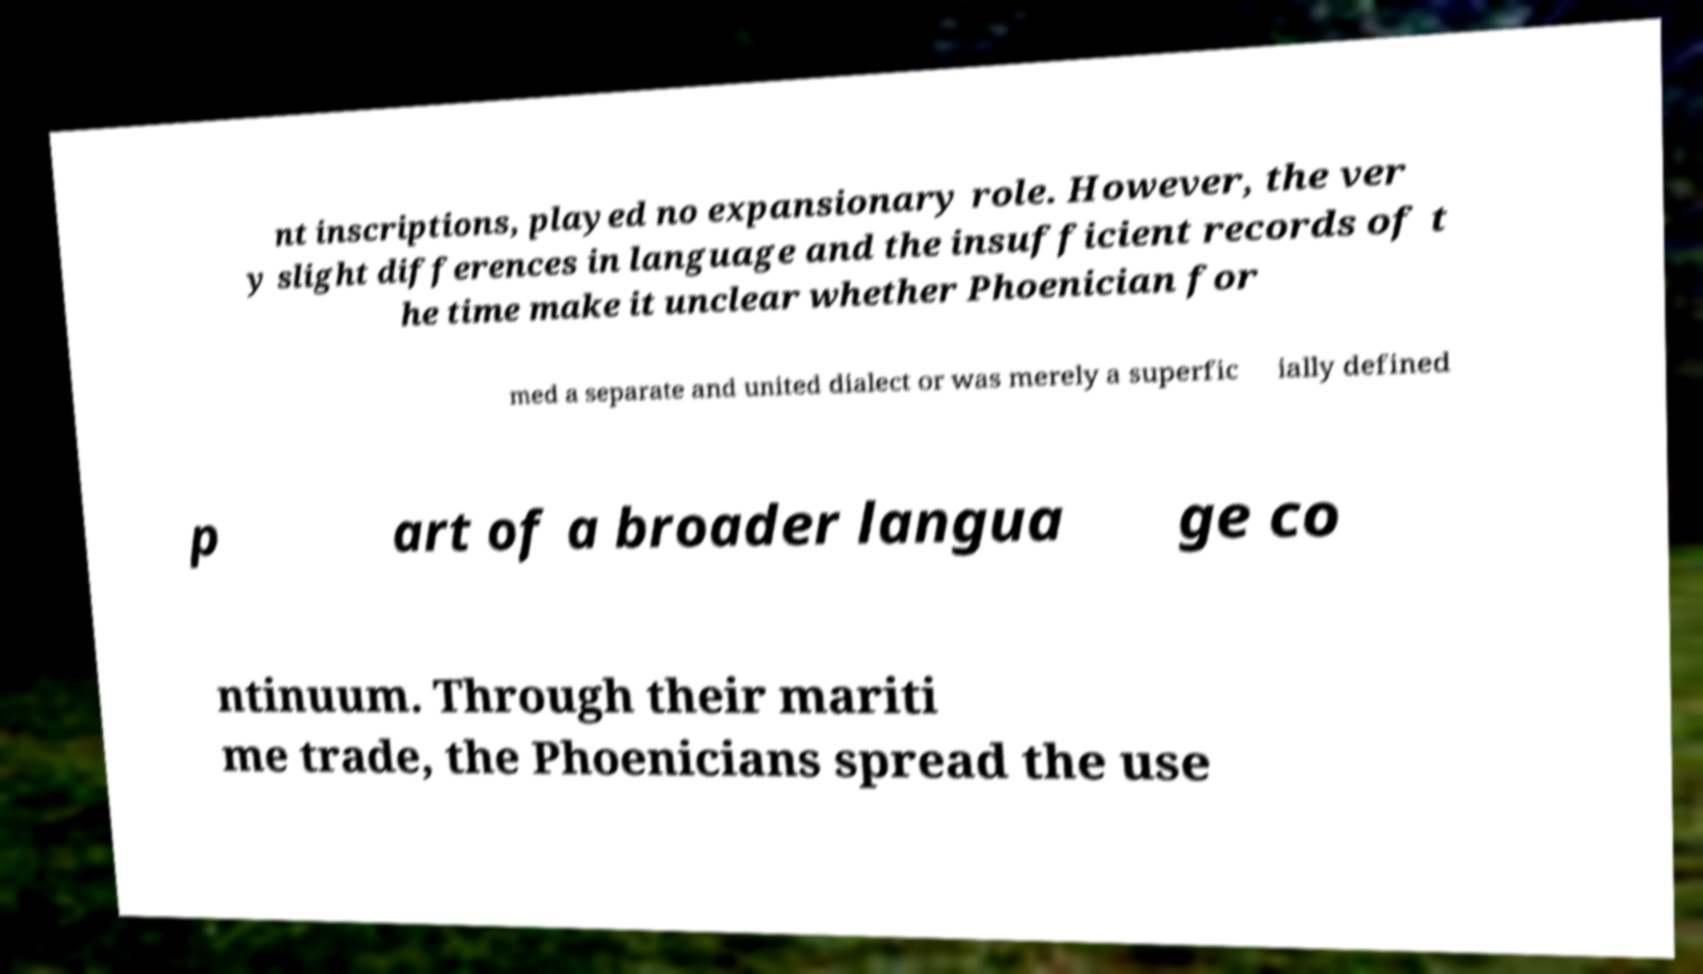Can you read and provide the text displayed in the image?This photo seems to have some interesting text. Can you extract and type it out for me? nt inscriptions, played no expansionary role. However, the ver y slight differences in language and the insufficient records of t he time make it unclear whether Phoenician for med a separate and united dialect or was merely a superfic ially defined p art of a broader langua ge co ntinuum. Through their mariti me trade, the Phoenicians spread the use 